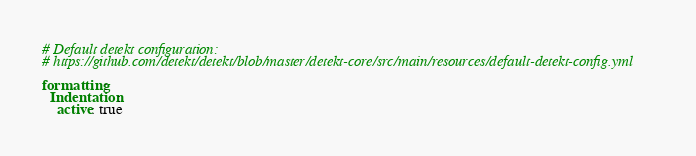<code> <loc_0><loc_0><loc_500><loc_500><_YAML_># Default detekt configuration:
# https://github.com/detekt/detekt/blob/master/detekt-core/src/main/resources/default-detekt-config.yml

formatting:
  Indentation:
    active: true
</code> 